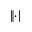<formula> <loc_0><loc_0><loc_500><loc_500>\| \cdot \|</formula> 